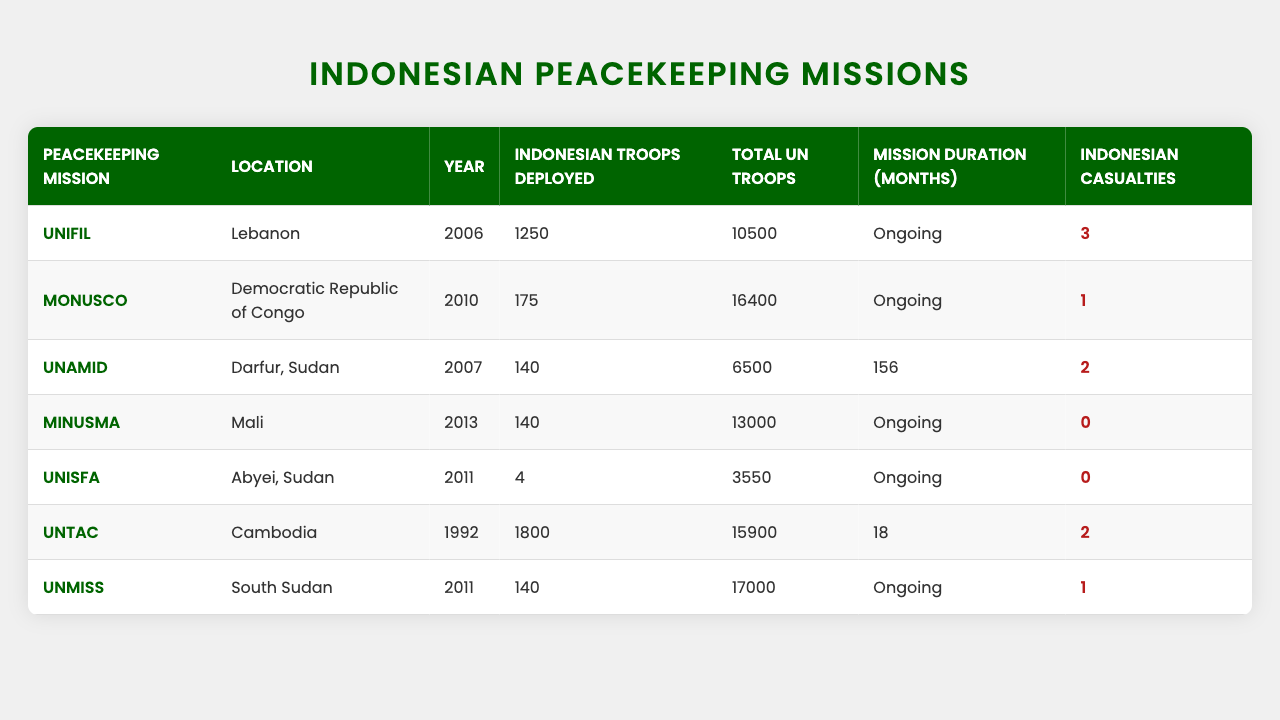What is the location of the UNIFIL mission? The table lists the locations of various peacekeeping missions. For UNIFIL, it shows "Lebanon" as the location.
Answer: Lebanon How many Indonesian troops were deployed to UNAMID? Looking at the data for UNAMID in the table, it states that 140 Indonesian troops were deployed.
Answer: 140 What year did Indonesia send troops to MINUSMA? By checking the "Year" column next to MINUSMA in the table, we see that Indonesian troops were deployed in 2013.
Answer: 2013 Which peacekeeping mission has the highest number of Indonesian troops deployed? Evaluating the "Indonesian Troops Deployed" column, the highest number is 1800 for the UNTAC mission in Cambodia.
Answer: UNTAC How many total UN troops were there in MONUSCO? Referring to the table, MONUSCO is associated with 16400 total UN troops deployed.
Answer: 16400 Did Indonesia incur more than 2 casualties in any mission? Reviewing the "Indonesian Casualties" column, we see that none of the missions has more than 2 casualties, so the answer is no.
Answer: No What is the average number of Indonesian troops deployed across all missions listed? First, we calculate the total number of Indonesian troops deployed: 1250 + 175 + 140 + 140 + 4 + 1800 + 140 = 2610. We divide this sum by the number of missions (7), which gives us an average of 2610 / 7 ≈ 373.
Answer: 373 Which mission lasted the longest based on the duration in months? The table shows durations for several missions; the longest duration is "Ongoing" for UNIFIL, MONUSCO, MINUSMA, UNISFA, and UNMISS, while UNAMID lasted 156 months and UNTAC lasted 18 months. Therefore, UNAMID has the longest fixed duration.
Answer: UNAMID What is the difference in the number of Indonesian troops deployed between UNIFIL and UNMISS? According to the table, UNIFIL had 1250 troops while UNMISS had 140. The difference is 1250 - 140 = 1110.
Answer: 1110 How many missions are still ongoing? By examining the "Mission Duration" column, we can see that UNIFIL, MONUSCO, MINUSMA, UNISFA, and UNMISS are all labeled as "Ongoing." Thus, there are 5 ongoing missions.
Answer: 5 